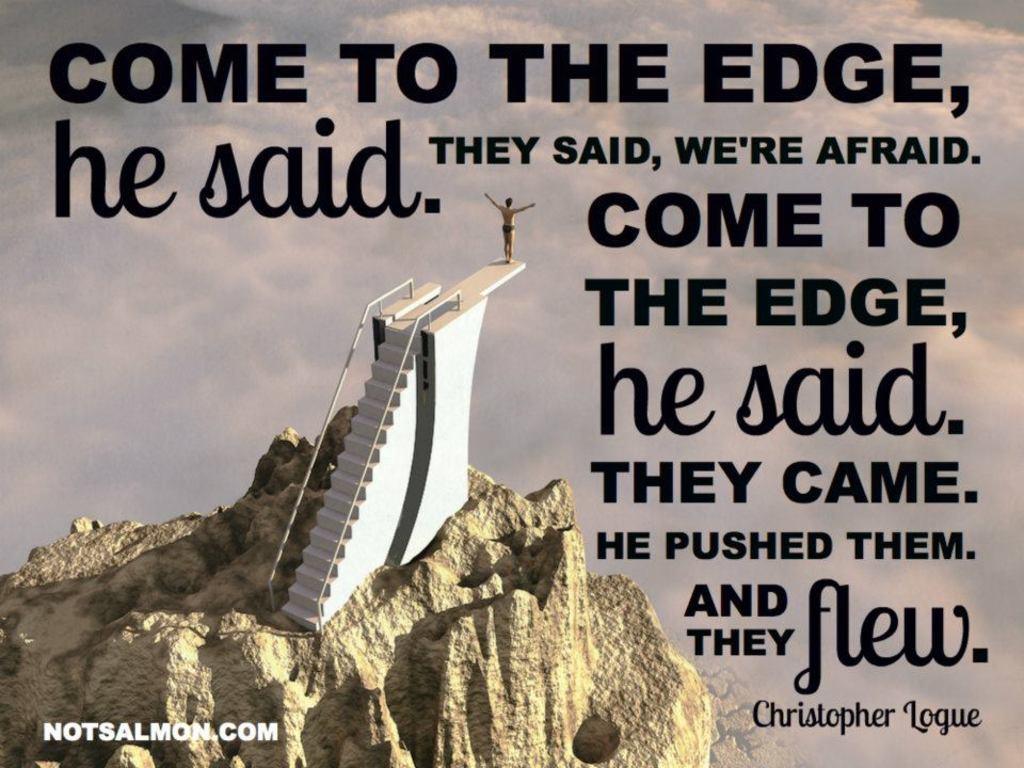<image>
Offer a succinct explanation of the picture presented. An inspiring picture and quote written by Christopher Logue. 